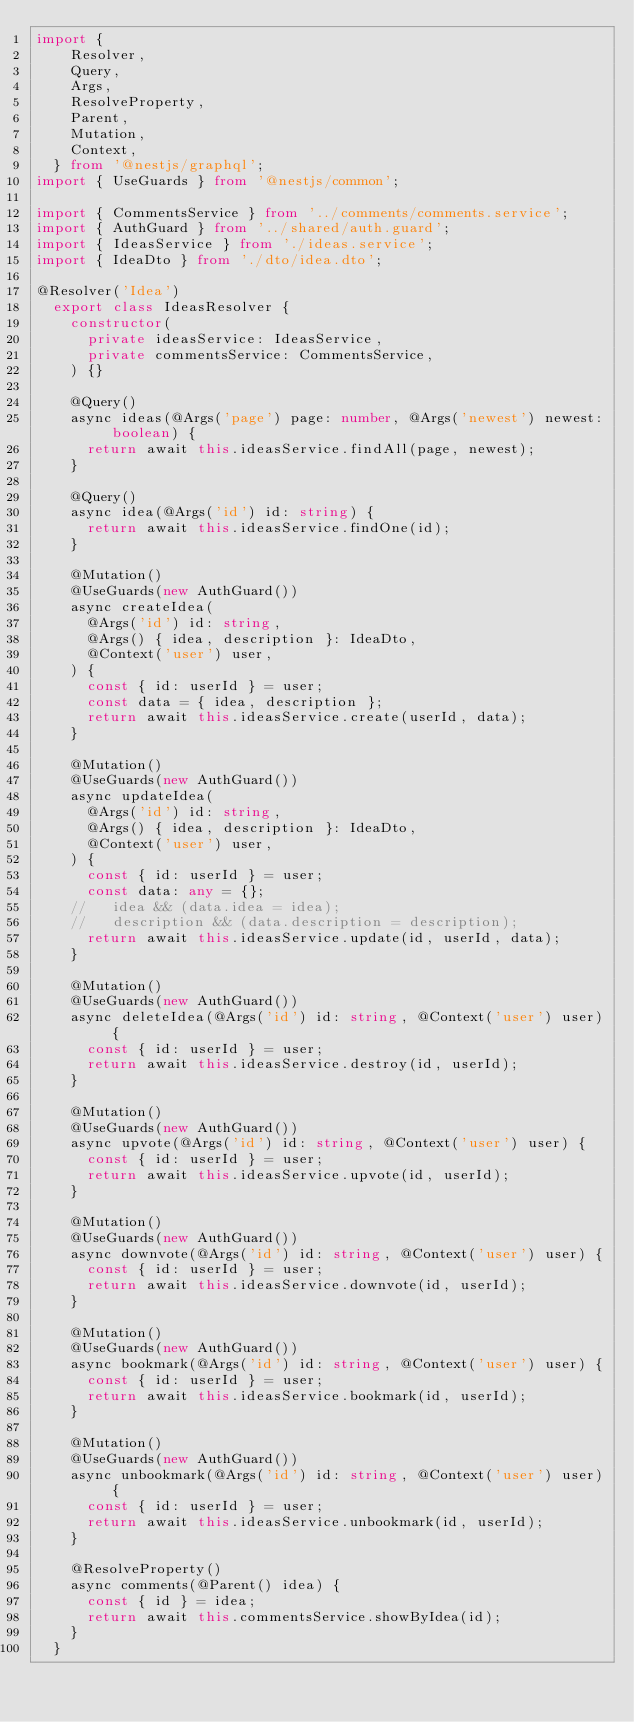<code> <loc_0><loc_0><loc_500><loc_500><_TypeScript_>import {
    Resolver,
    Query,
    Args,
    ResolveProperty,
    Parent,
    Mutation,
    Context,
  } from '@nestjs/graphql';
import { UseGuards } from '@nestjs/common';

import { CommentsService } from '../comments/comments.service';
import { AuthGuard } from '../shared/auth.guard';
import { IdeasService } from './ideas.service';
import { IdeaDto } from './dto/idea.dto';

@Resolver('Idea')
  export class IdeasResolver {
    constructor(
      private ideasService: IdeasService,
      private commentsService: CommentsService,
    ) {}

    @Query()
    async ideas(@Args('page') page: number, @Args('newest') newest: boolean) {
      return await this.ideasService.findAll(page, newest);
    }

    @Query()
    async idea(@Args('id') id: string) {
      return await this.ideasService.findOne(id);
    }

    @Mutation()
    @UseGuards(new AuthGuard())
    async createIdea(
      @Args('id') id: string,
      @Args() { idea, description }: IdeaDto,
      @Context('user') user,
    ) {
      const { id: userId } = user;
      const data = { idea, description };
      return await this.ideasService.create(userId, data);
    }

    @Mutation()
    @UseGuards(new AuthGuard())
    async updateIdea(
      @Args('id') id: string,
      @Args() { idea, description }: IdeaDto,
      @Context('user') user,
    ) {
      const { id: userId } = user;
      const data: any = {};
    //   idea && (data.idea = idea);
    //   description && (data.description = description);
      return await this.ideasService.update(id, userId, data);
    }

    @Mutation()
    @UseGuards(new AuthGuard())
    async deleteIdea(@Args('id') id: string, @Context('user') user) {
      const { id: userId } = user;
      return await this.ideasService.destroy(id, userId);
    }

    @Mutation()
    @UseGuards(new AuthGuard())
    async upvote(@Args('id') id: string, @Context('user') user) {
      const { id: userId } = user;
      return await this.ideasService.upvote(id, userId);
    }

    @Mutation()
    @UseGuards(new AuthGuard())
    async downvote(@Args('id') id: string, @Context('user') user) {
      const { id: userId } = user;
      return await this.ideasService.downvote(id, userId);
    }

    @Mutation()
    @UseGuards(new AuthGuard())
    async bookmark(@Args('id') id: string, @Context('user') user) {
      const { id: userId } = user;
      return await this.ideasService.bookmark(id, userId);
    }

    @Mutation()
    @UseGuards(new AuthGuard())
    async unbookmark(@Args('id') id: string, @Context('user') user) {
      const { id: userId } = user;
      return await this.ideasService.unbookmark(id, userId);
    }

    @ResolveProperty()
    async comments(@Parent() idea) {
      const { id } = idea;
      return await this.commentsService.showByIdea(id);
    }
  }
</code> 